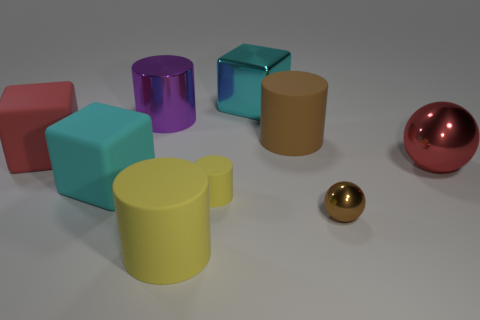Is there a yellow cylinder that is left of the large yellow cylinder that is to the left of the large red ball?
Your answer should be very brief. No. There is a brown thing that is in front of the brown rubber object; is its shape the same as the red metallic object?
Provide a short and direct response. Yes. What number of cubes are either cyan matte things or big objects?
Provide a short and direct response. 3. How many big green cylinders are there?
Make the answer very short. 0. There is a sphere that is in front of the yellow rubber cylinder that is behind the large yellow cylinder; what size is it?
Your answer should be very brief. Small. How many other things are there of the same size as the purple cylinder?
Keep it short and to the point. 6. What number of big red blocks are in front of the large yellow thing?
Keep it short and to the point. 0. The purple shiny object is what size?
Offer a very short reply. Large. Is the material of the cyan thing that is to the left of the small yellow object the same as the tiny object that is on the left side of the large cyan metal thing?
Your answer should be compact. Yes. Is there a large rubber thing that has the same color as the large shiny block?
Give a very brief answer. Yes. 